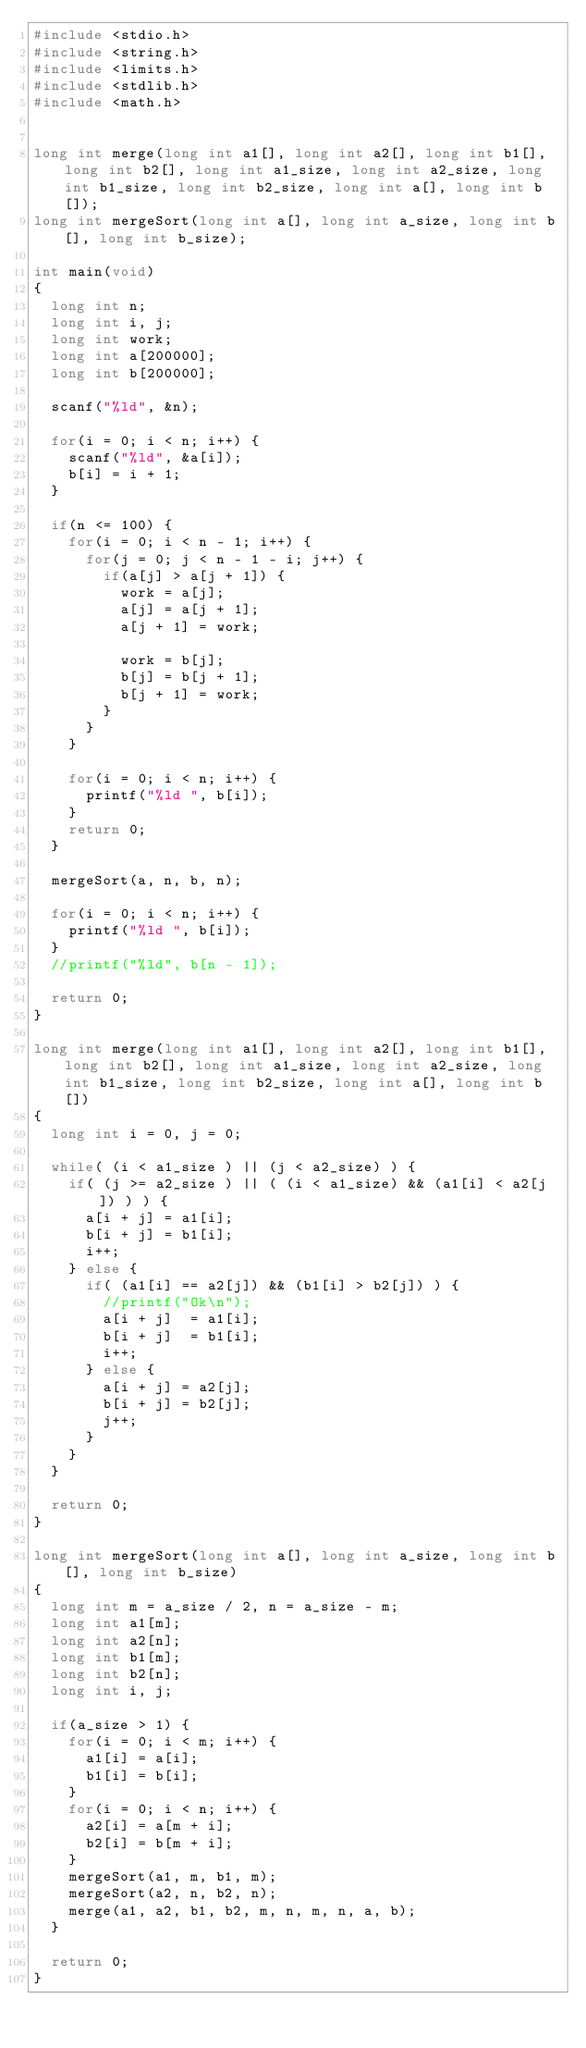<code> <loc_0><loc_0><loc_500><loc_500><_C_>#include <stdio.h>
#include <string.h>
#include <limits.h>
#include <stdlib.h>
#include <math.h>


long int merge(long int a1[], long int a2[], long int b1[], long int b2[], long int a1_size, long int a2_size, long int b1_size, long int b2_size, long int a[], long int b[]);
long int mergeSort(long int a[], long int a_size, long int b[], long int b_size);

int main(void)
{
	long int n;
	long int i, j;
	long int work;
	long int a[200000];
	long int b[200000];
	
	scanf("%ld", &n);
	
	for(i = 0; i < n; i++) {
		scanf("%ld", &a[i]);
		b[i] = i + 1;
	}
	
	if(n <= 100) {
		for(i = 0; i < n - 1; i++) {
			for(j = 0; j < n - 1 - i; j++) {
				if(a[j] > a[j + 1]) {
					work = a[j];
					a[j] = a[j + 1];
					a[j + 1] = work;
					
					work = b[j];
					b[j] = b[j + 1];
					b[j + 1] = work;
				}
			}
		}
		
		for(i = 0; i < n; i++) {
			printf("%ld ", b[i]);
		}
		return 0;
	}
	
	mergeSort(a, n, b, n);
	
	for(i = 0; i < n; i++) {
		printf("%ld ", b[i]);
	}
	//printf("%ld", b[n - 1]);
	
	return 0;
}

long int merge(long int a1[], long int a2[], long int b1[], long int b2[], long int a1_size, long int a2_size, long int b1_size, long int b2_size, long int a[], long int b[])
{
	long int i = 0, j = 0;
	
	while( (i < a1_size ) || (j < a2_size) ) {
		if( (j >= a2_size ) || ( (i < a1_size) && (a1[i] < a2[j]) ) ) {
			a[i + j] = a1[i];
			b[i + j] = b1[i];
			i++;
		} else {
			if( (a1[i] == a2[j]) && (b1[i] > b2[j]) ) {
				//printf("Ok\n");
				a[i + j]  = a1[i];
				b[i + j]  = b1[i];
				i++;
			} else {
				a[i + j] = a2[j];
				b[i + j] = b2[j];
				j++;
			}
		}
	}
	
	return 0;
}

long int mergeSort(long int a[], long int a_size, long int b[], long int b_size)
{
	long int m = a_size / 2, n = a_size - m;
	long int a1[m];
	long int a2[n];
	long int b1[m];
	long int b2[n];
	long int i, j;
	
	if(a_size > 1) {
		for(i = 0; i < m; i++) {
			a1[i] = a[i];
			b1[i] = b[i];
		}
		for(i = 0; i < n; i++) {
			a2[i] = a[m + i];
			b2[i] = b[m + i];
		}
		mergeSort(a1, m, b1, m);
		mergeSort(a2, n, b2, n);
		merge(a1, a2, b1, b2, m, n, m, n, a, b);
	}
	
	return 0;
}
</code> 